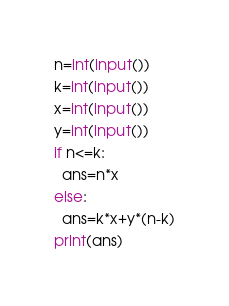Convert code to text. <code><loc_0><loc_0><loc_500><loc_500><_Python_>n=int(input())
k=int(input())
x=int(input())
y=int(input())
if n<=k:
  ans=n*x
else:
  ans=k*x+y*(n-k)
print(ans)</code> 